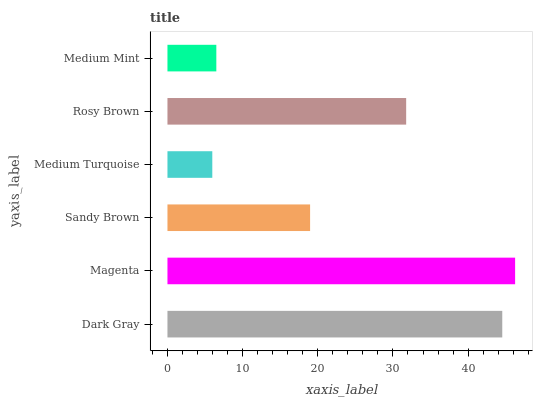Is Medium Turquoise the minimum?
Answer yes or no. Yes. Is Magenta the maximum?
Answer yes or no. Yes. Is Sandy Brown the minimum?
Answer yes or no. No. Is Sandy Brown the maximum?
Answer yes or no. No. Is Magenta greater than Sandy Brown?
Answer yes or no. Yes. Is Sandy Brown less than Magenta?
Answer yes or no. Yes. Is Sandy Brown greater than Magenta?
Answer yes or no. No. Is Magenta less than Sandy Brown?
Answer yes or no. No. Is Rosy Brown the high median?
Answer yes or no. Yes. Is Sandy Brown the low median?
Answer yes or no. Yes. Is Dark Gray the high median?
Answer yes or no. No. Is Medium Turquoise the low median?
Answer yes or no. No. 